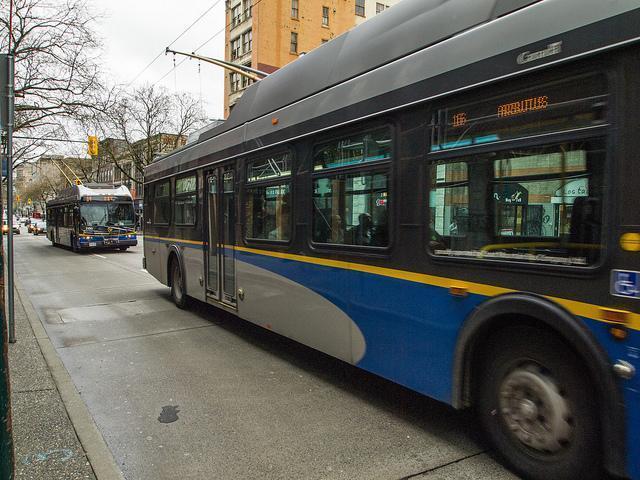How many buses are there?
Give a very brief answer. 2. How many cups are on the table?
Give a very brief answer. 0. 